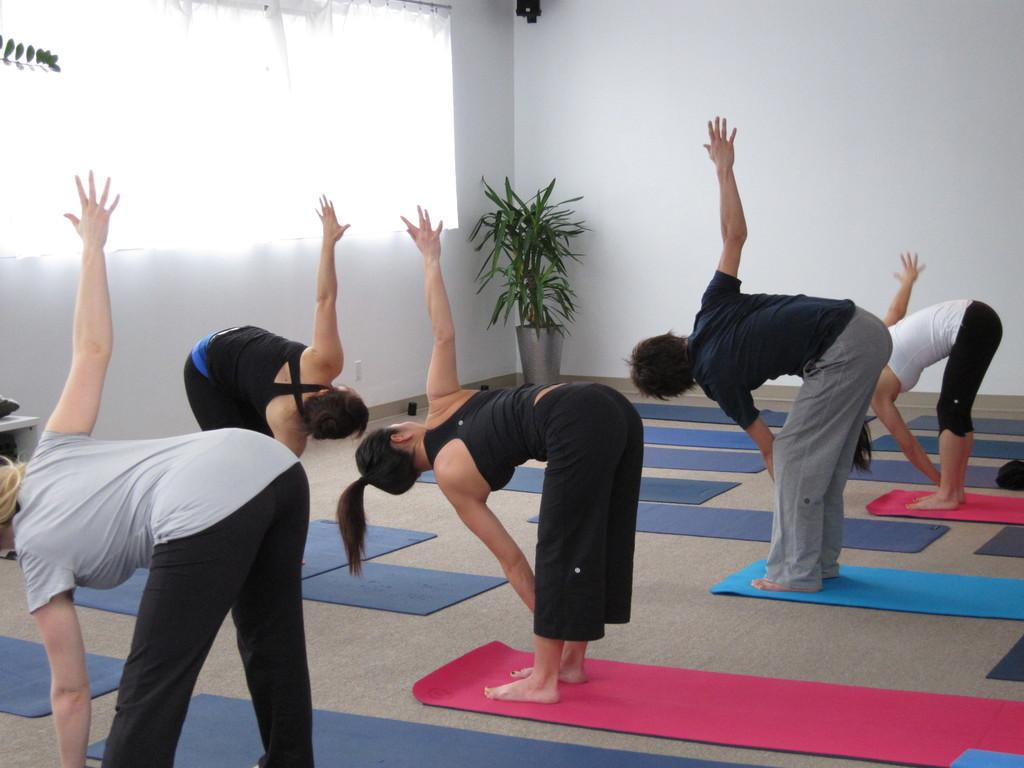What are the people in the image doing? The people in the image are performing yoga. Can you describe the plant on the left side of the image? There is a plant on the left side of the image, but its specific characteristics are not mentioned in the facts. What is on the right side of the image? There is a wall on the right side of the image. Where is the fireman in the image? There is no fireman present in the image. What type of mask is being worn by the person in the image? There is no mention of a mask or any person wearing a mask in the image. 